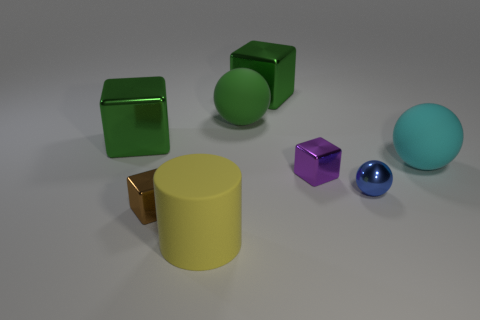Are there any patterns or arrangements that the objects form in this image? In this image, the objects seem to be placed without a specific pattern in mind. However, they do form a loose diagonal line from the bottom left to the top right of the scene. This arrangement creates a sense of movement and directs the viewer's eye through the image. The varying sizes and colors of the objects enhance the visual interest. 